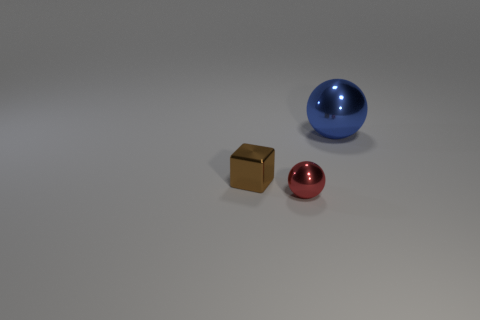Add 1 tiny gray rubber objects. How many objects exist? 4 Subtract all balls. How many objects are left? 1 Add 1 brown objects. How many brown objects are left? 2 Add 3 big blue objects. How many big blue objects exist? 4 Subtract 0 red cubes. How many objects are left? 3 Subtract all large balls. Subtract all small gray metal blocks. How many objects are left? 2 